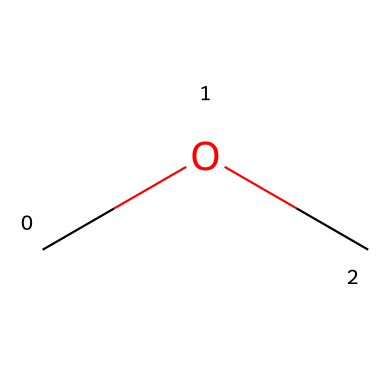What is the name of this chemical? The structure corresponds to the SMILES representation "COC", which indicates it is dimethyl ether, where 'C' represents carbon atoms and 'O' represents an oxygen atom.
Answer: dimethyl ether How many carbon atoms are present in this molecule? The SMILES representation "COC" shows two 'C' atoms, which indicates that there are 2 carbon atoms in dimethyl ether.
Answer: 2 What is the functional group of this compound? Dimethyl ether contains an ether functional group, characterized by the presence of the oxygen atom bonded to two alkyl or aryl groups (in this case, two methyl groups).
Answer: ether What is the total number of hydrogen atoms in this molecule? Each carbon atom in dimethyl ether is bonded to three hydrogen atoms, and since there are 2 carbon atoms, there are a total of 6 hydrogen atoms (3 from each carbon).
Answer: 6 Is dimethyl ether flammable? Dimethyl ether is known to be flammable due to its volatile nature and the presence of carbon and hydrogen atoms that can undergo combustion.
Answer: yes Can dimethyl ether be used as a propellant? The structure and low molecular weight of dimethyl ether make it suitable for use as a propellant in aerosol sprays, providing the necessary pressure for expulsion.
Answer: yes What distinguishes dimethyl ether from alcohols? Dimethyl ether does not have a hydroxyl group (-OH), which is present in alcohols, despite having similar carbon and hydrogen content.
Answer: no 